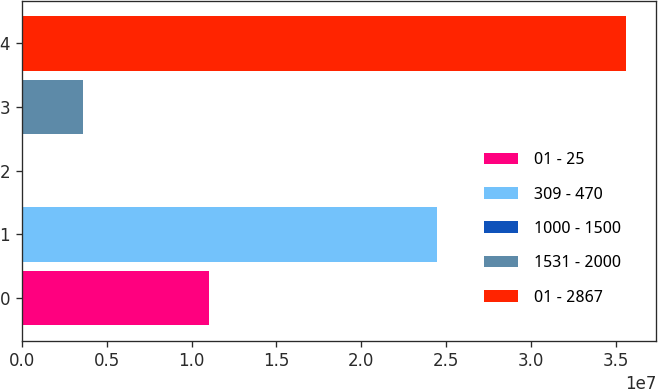Convert chart to OTSL. <chart><loc_0><loc_0><loc_500><loc_500><bar_chart><fcel>01 - 25<fcel>309 - 470<fcel>1000 - 1500<fcel>1531 - 2000<fcel>01 - 2867<nl><fcel>1.10228e+07<fcel>2.44385e+07<fcel>60075<fcel>3.61314e+06<fcel>3.55908e+07<nl></chart> 